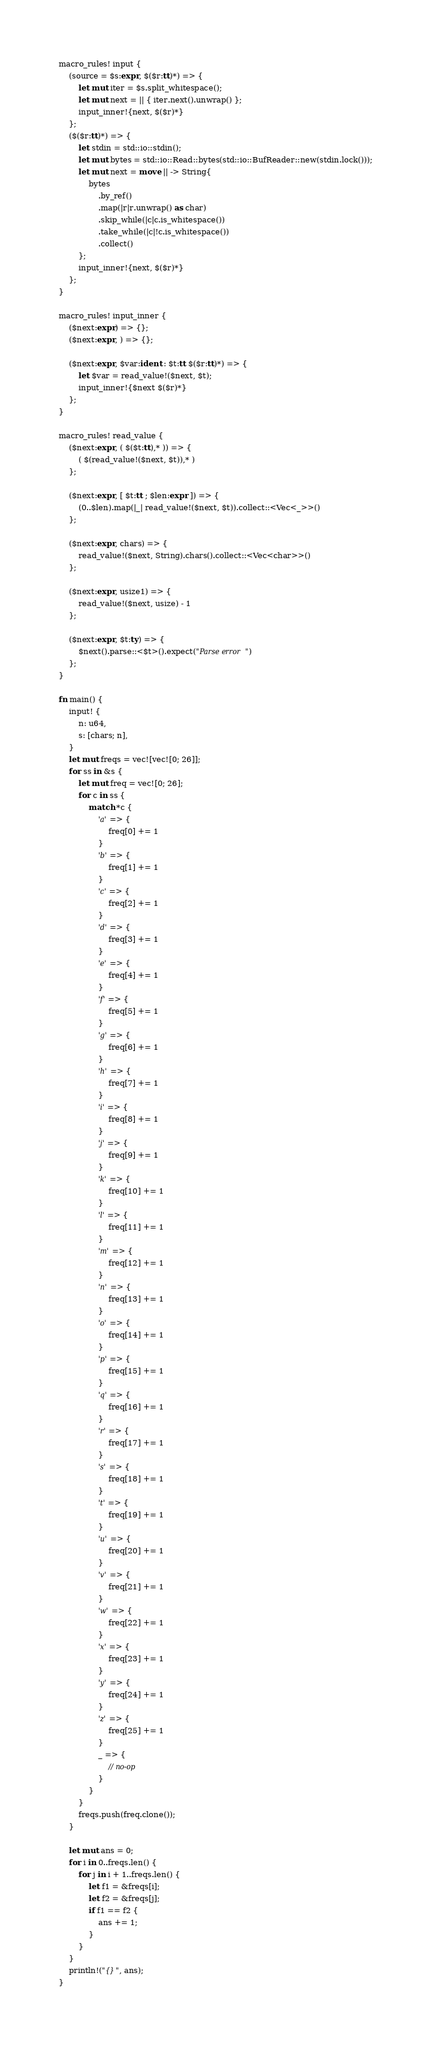Convert code to text. <code><loc_0><loc_0><loc_500><loc_500><_Rust_>macro_rules! input {
    (source = $s:expr, $($r:tt)*) => {
        let mut iter = $s.split_whitespace();
        let mut next = || { iter.next().unwrap() };
        input_inner!{next, $($r)*}
    };
    ($($r:tt)*) => {
        let stdin = std::io::stdin();
        let mut bytes = std::io::Read::bytes(std::io::BufReader::new(stdin.lock()));
        let mut next = move || -> String{
            bytes
                .by_ref()
                .map(|r|r.unwrap() as char)
                .skip_while(|c|c.is_whitespace())
                .take_while(|c|!c.is_whitespace())
                .collect()
        };
        input_inner!{next, $($r)*}
    };
}

macro_rules! input_inner {
    ($next:expr) => {};
    ($next:expr, ) => {};

    ($next:expr, $var:ident : $t:tt $($r:tt)*) => {
        let $var = read_value!($next, $t);
        input_inner!{$next $($r)*}
    };
}

macro_rules! read_value {
    ($next:expr, ( $($t:tt),* )) => {
        ( $(read_value!($next, $t)),* )
    };

    ($next:expr, [ $t:tt ; $len:expr ]) => {
        (0..$len).map(|_| read_value!($next, $t)).collect::<Vec<_>>()
    };

    ($next:expr, chars) => {
        read_value!($next, String).chars().collect::<Vec<char>>()
    };

    ($next:expr, usize1) => {
        read_value!($next, usize) - 1
    };

    ($next:expr, $t:ty) => {
        $next().parse::<$t>().expect("Parse error")
    };
}

fn main() {
    input! {
        n: u64,
        s: [chars; n],
    }
    let mut freqs = vec![vec![0; 26]];
    for ss in &s {
        let mut freq = vec![0; 26];
        for c in ss {
            match *c {
                'a' => {
                    freq[0] += 1
                }
                'b' => {
                    freq[1] += 1
                }
                'c' => {
                    freq[2] += 1
                }
                'd' => {
                    freq[3] += 1
                }
                'e' => {
                    freq[4] += 1
                }
                'f' => {
                    freq[5] += 1
                }
                'g' => {
                    freq[6] += 1
                }
                'h' => {
                    freq[7] += 1
                }
                'i' => {
                    freq[8] += 1
                }
                'j' => {
                    freq[9] += 1
                }
                'k' => {
                    freq[10] += 1
                }
                'l' => {
                    freq[11] += 1
                }
                'm' => {
                    freq[12] += 1
                }
                'n' => {
                    freq[13] += 1
                }
                'o' => {
                    freq[14] += 1
                }
                'p' => {
                    freq[15] += 1
                }
                'q' => {
                    freq[16] += 1
                }
                'r' => {
                    freq[17] += 1
                }
                's' => {
                    freq[18] += 1
                }
                't' => {
                    freq[19] += 1
                }
                'u' => {
                    freq[20] += 1
                }
                'v' => {
                    freq[21] += 1
                }
                'w' => {
                    freq[22] += 1
                }
                'x' => {
                    freq[23] += 1
                }
                'y' => {
                    freq[24] += 1
                }
                'z' => {
                    freq[25] += 1
                }
                _ => {
                    // no-op
                }
            }
        }
        freqs.push(freq.clone());
    }

    let mut ans = 0;
    for i in 0..freqs.len() {
        for j in i + 1..freqs.len() {
            let f1 = &freqs[i];
            let f2 = &freqs[j];
            if f1 == f2 {
                ans += 1;
            }
        }
    }
    println!("{}", ans);
}

</code> 